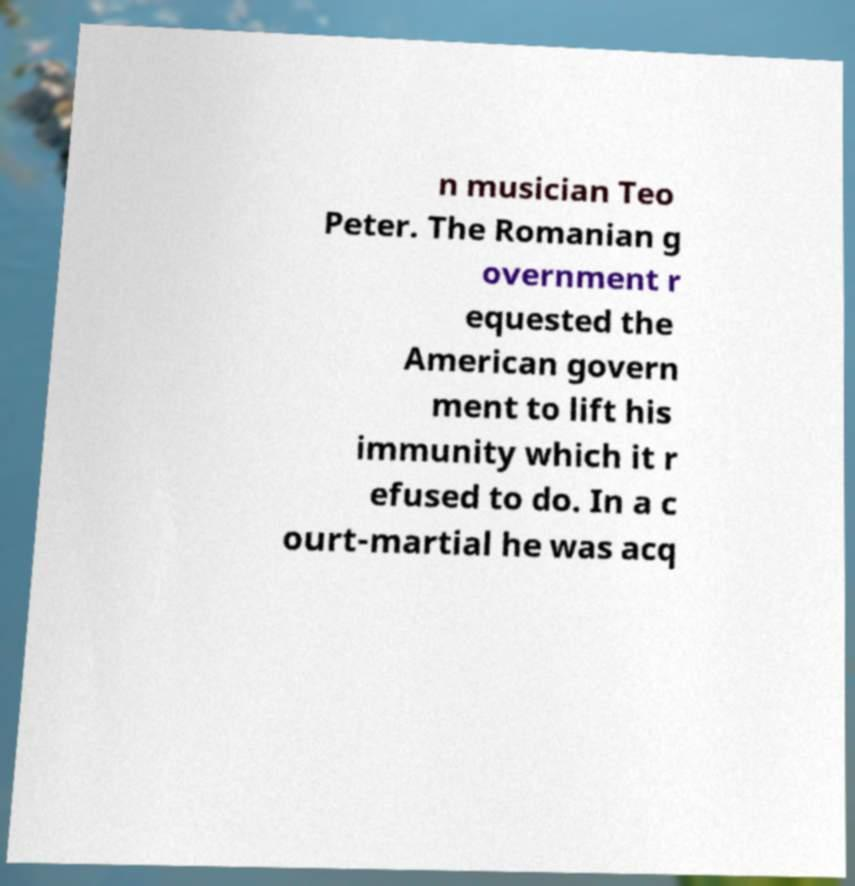Can you read and provide the text displayed in the image?This photo seems to have some interesting text. Can you extract and type it out for me? n musician Teo Peter. The Romanian g overnment r equested the American govern ment to lift his immunity which it r efused to do. In a c ourt-martial he was acq 